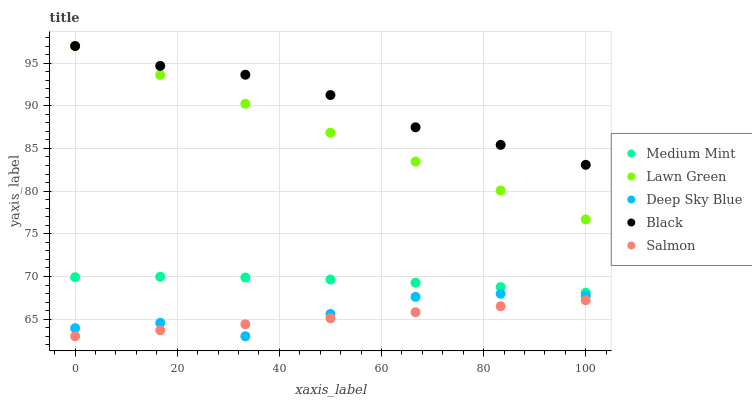Does Salmon have the minimum area under the curve?
Answer yes or no. Yes. Does Black have the maximum area under the curve?
Answer yes or no. Yes. Does Lawn Green have the minimum area under the curve?
Answer yes or no. No. Does Lawn Green have the maximum area under the curve?
Answer yes or no. No. Is Salmon the smoothest?
Answer yes or no. Yes. Is Deep Sky Blue the roughest?
Answer yes or no. Yes. Is Lawn Green the smoothest?
Answer yes or no. No. Is Lawn Green the roughest?
Answer yes or no. No. Does Deep Sky Blue have the lowest value?
Answer yes or no. Yes. Does Lawn Green have the lowest value?
Answer yes or no. No. Does Black have the highest value?
Answer yes or no. Yes. Does Deep Sky Blue have the highest value?
Answer yes or no. No. Is Medium Mint less than Lawn Green?
Answer yes or no. Yes. Is Black greater than Deep Sky Blue?
Answer yes or no. Yes. Does Deep Sky Blue intersect Salmon?
Answer yes or no. Yes. Is Deep Sky Blue less than Salmon?
Answer yes or no. No. Is Deep Sky Blue greater than Salmon?
Answer yes or no. No. Does Medium Mint intersect Lawn Green?
Answer yes or no. No. 